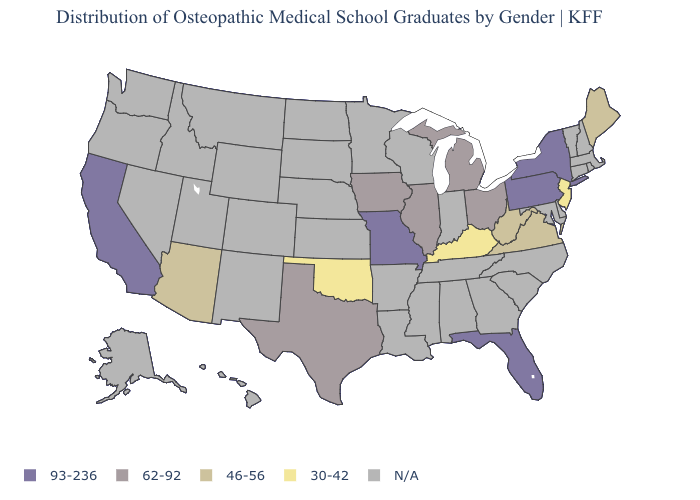Name the states that have a value in the range 62-92?
Give a very brief answer. Illinois, Iowa, Michigan, Ohio, Texas. Does the map have missing data?
Answer briefly. Yes. Among the states that border North Carolina , which have the highest value?
Answer briefly. Virginia. What is the highest value in the USA?
Answer briefly. 93-236. What is the value of Hawaii?
Short answer required. N/A. Among the states that border Connecticut , which have the highest value?
Answer briefly. New York. Does the map have missing data?
Quick response, please. Yes. What is the value of Utah?
Quick response, please. N/A. Does the map have missing data?
Keep it brief. Yes. Name the states that have a value in the range 93-236?
Be succinct. California, Florida, Missouri, New York, Pennsylvania. What is the value of South Carolina?
Keep it brief. N/A. Does New Jersey have the lowest value in the USA?
Give a very brief answer. Yes. What is the value of North Dakota?
Be succinct. N/A. Name the states that have a value in the range 46-56?
Answer briefly. Arizona, Maine, Virginia, West Virginia. Which states have the lowest value in the USA?
Short answer required. Kentucky, New Jersey, Oklahoma. 